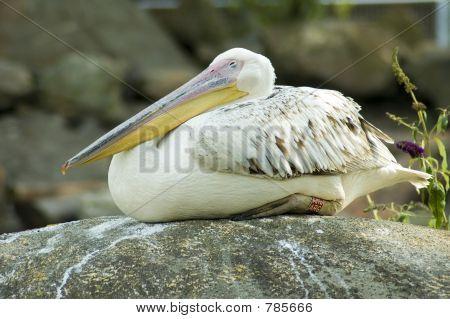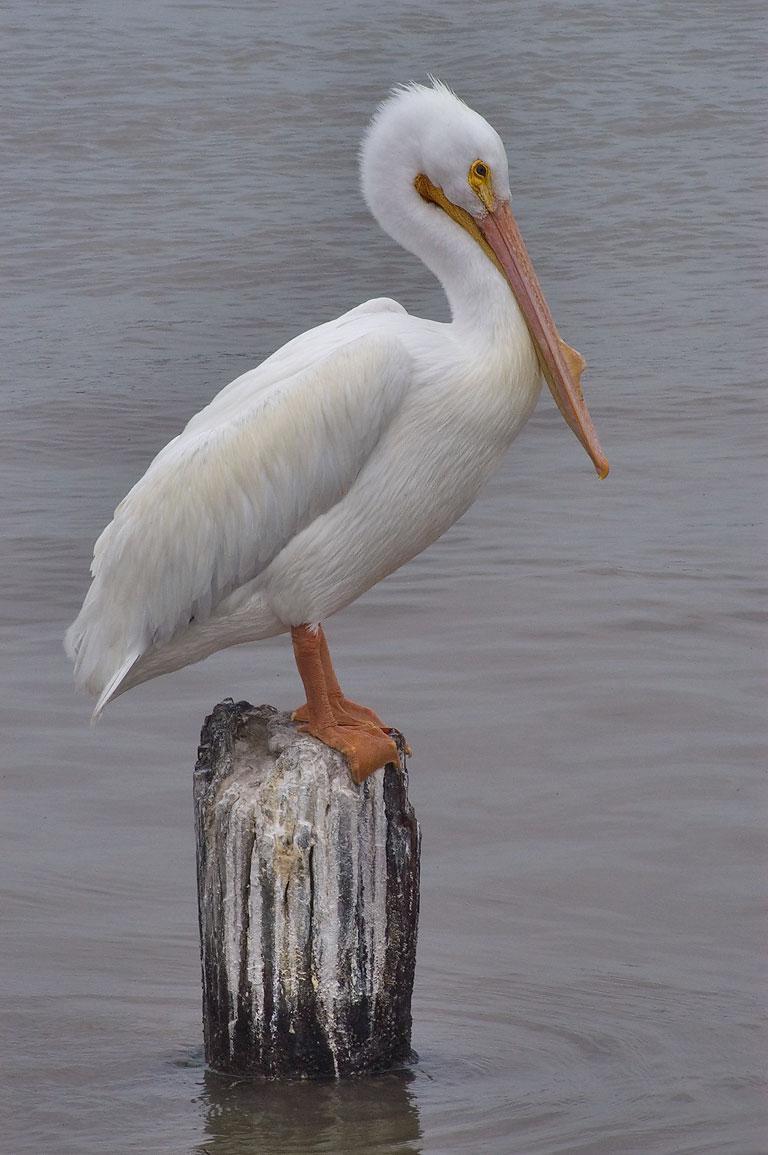The first image is the image on the left, the second image is the image on the right. For the images shown, is this caption "One bird is on a pole pointed to the right." true? Answer yes or no. Yes. 